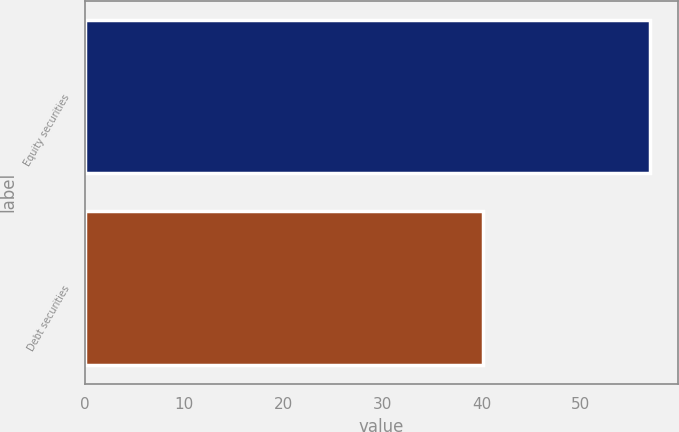<chart> <loc_0><loc_0><loc_500><loc_500><bar_chart><fcel>Equity securities<fcel>Debt securities<nl><fcel>57<fcel>40.2<nl></chart> 